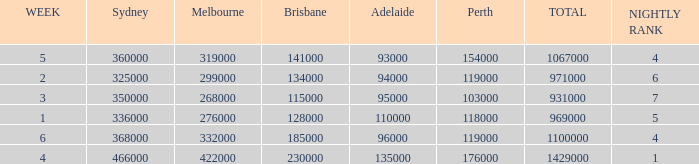What was the rating in Brisbane the week it was 276000 in Melbourne?  128000.0. 